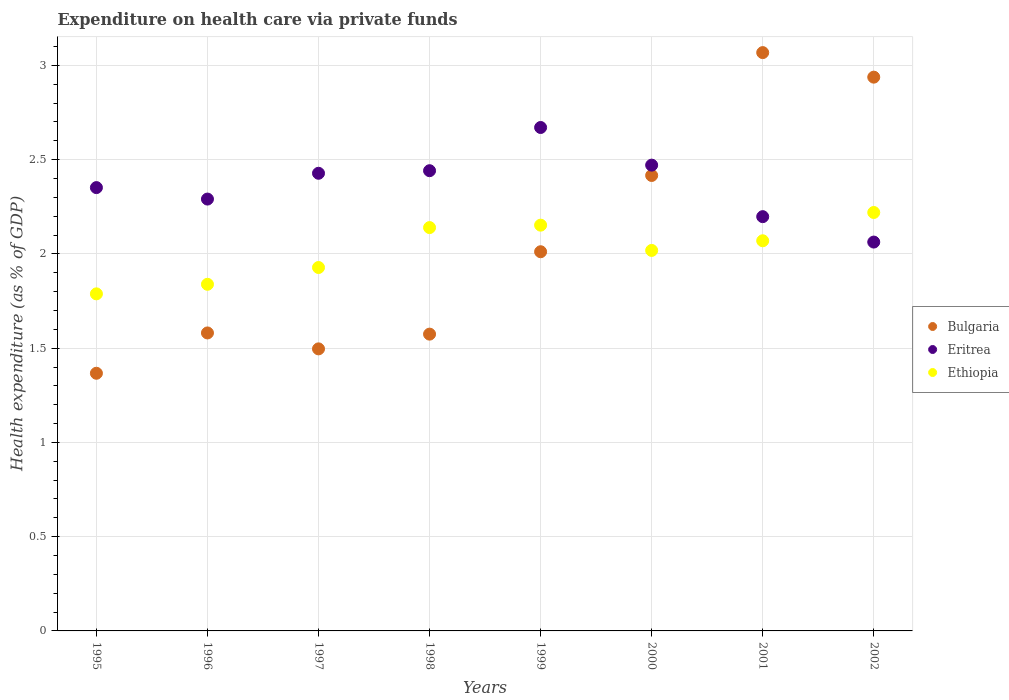Is the number of dotlines equal to the number of legend labels?
Your answer should be very brief. Yes. What is the expenditure made on health care in Ethiopia in 1996?
Provide a succinct answer. 1.84. Across all years, what is the maximum expenditure made on health care in Eritrea?
Your answer should be compact. 2.67. Across all years, what is the minimum expenditure made on health care in Eritrea?
Your response must be concise. 2.06. In which year was the expenditure made on health care in Ethiopia maximum?
Your answer should be compact. 2002. What is the total expenditure made on health care in Ethiopia in the graph?
Ensure brevity in your answer.  16.16. What is the difference between the expenditure made on health care in Eritrea in 1998 and that in 2002?
Your answer should be compact. 0.38. What is the difference between the expenditure made on health care in Ethiopia in 1998 and the expenditure made on health care in Bulgaria in 2001?
Make the answer very short. -0.93. What is the average expenditure made on health care in Ethiopia per year?
Give a very brief answer. 2.02. In the year 1997, what is the difference between the expenditure made on health care in Bulgaria and expenditure made on health care in Ethiopia?
Offer a very short reply. -0.43. What is the ratio of the expenditure made on health care in Ethiopia in 1995 to that in 2001?
Provide a short and direct response. 0.86. Is the expenditure made on health care in Bulgaria in 1995 less than that in 2001?
Give a very brief answer. Yes. What is the difference between the highest and the second highest expenditure made on health care in Ethiopia?
Ensure brevity in your answer.  0.07. What is the difference between the highest and the lowest expenditure made on health care in Ethiopia?
Give a very brief answer. 0.43. In how many years, is the expenditure made on health care in Ethiopia greater than the average expenditure made on health care in Ethiopia taken over all years?
Your answer should be very brief. 4. Is the sum of the expenditure made on health care in Eritrea in 1998 and 1999 greater than the maximum expenditure made on health care in Ethiopia across all years?
Provide a short and direct response. Yes. Is it the case that in every year, the sum of the expenditure made on health care in Ethiopia and expenditure made on health care in Eritrea  is greater than the expenditure made on health care in Bulgaria?
Ensure brevity in your answer.  Yes. Does the expenditure made on health care in Bulgaria monotonically increase over the years?
Offer a very short reply. No. Is the expenditure made on health care in Bulgaria strictly greater than the expenditure made on health care in Ethiopia over the years?
Your answer should be compact. No. How many dotlines are there?
Ensure brevity in your answer.  3. How many years are there in the graph?
Your response must be concise. 8. What is the difference between two consecutive major ticks on the Y-axis?
Your response must be concise. 0.5. Does the graph contain grids?
Offer a very short reply. Yes. Where does the legend appear in the graph?
Keep it short and to the point. Center right. How many legend labels are there?
Offer a very short reply. 3. What is the title of the graph?
Your answer should be compact. Expenditure on health care via private funds. What is the label or title of the X-axis?
Ensure brevity in your answer.  Years. What is the label or title of the Y-axis?
Give a very brief answer. Health expenditure (as % of GDP). What is the Health expenditure (as % of GDP) of Bulgaria in 1995?
Your answer should be compact. 1.37. What is the Health expenditure (as % of GDP) in Eritrea in 1995?
Your response must be concise. 2.35. What is the Health expenditure (as % of GDP) of Ethiopia in 1995?
Your answer should be very brief. 1.79. What is the Health expenditure (as % of GDP) of Bulgaria in 1996?
Offer a terse response. 1.58. What is the Health expenditure (as % of GDP) of Eritrea in 1996?
Your response must be concise. 2.29. What is the Health expenditure (as % of GDP) in Ethiopia in 1996?
Provide a succinct answer. 1.84. What is the Health expenditure (as % of GDP) of Bulgaria in 1997?
Offer a terse response. 1.5. What is the Health expenditure (as % of GDP) in Eritrea in 1997?
Keep it short and to the point. 2.43. What is the Health expenditure (as % of GDP) of Ethiopia in 1997?
Your answer should be very brief. 1.93. What is the Health expenditure (as % of GDP) in Bulgaria in 1998?
Your answer should be very brief. 1.57. What is the Health expenditure (as % of GDP) in Eritrea in 1998?
Provide a short and direct response. 2.44. What is the Health expenditure (as % of GDP) of Ethiopia in 1998?
Your answer should be very brief. 2.14. What is the Health expenditure (as % of GDP) in Bulgaria in 1999?
Your answer should be compact. 2.01. What is the Health expenditure (as % of GDP) of Eritrea in 1999?
Provide a succinct answer. 2.67. What is the Health expenditure (as % of GDP) of Ethiopia in 1999?
Give a very brief answer. 2.15. What is the Health expenditure (as % of GDP) of Bulgaria in 2000?
Keep it short and to the point. 2.42. What is the Health expenditure (as % of GDP) of Eritrea in 2000?
Offer a terse response. 2.47. What is the Health expenditure (as % of GDP) in Ethiopia in 2000?
Provide a short and direct response. 2.02. What is the Health expenditure (as % of GDP) of Bulgaria in 2001?
Offer a very short reply. 3.07. What is the Health expenditure (as % of GDP) of Eritrea in 2001?
Your response must be concise. 2.2. What is the Health expenditure (as % of GDP) in Ethiopia in 2001?
Keep it short and to the point. 2.07. What is the Health expenditure (as % of GDP) of Bulgaria in 2002?
Offer a very short reply. 2.94. What is the Health expenditure (as % of GDP) of Eritrea in 2002?
Make the answer very short. 2.06. What is the Health expenditure (as % of GDP) of Ethiopia in 2002?
Provide a succinct answer. 2.22. Across all years, what is the maximum Health expenditure (as % of GDP) of Bulgaria?
Offer a very short reply. 3.07. Across all years, what is the maximum Health expenditure (as % of GDP) of Eritrea?
Keep it short and to the point. 2.67. Across all years, what is the maximum Health expenditure (as % of GDP) of Ethiopia?
Provide a succinct answer. 2.22. Across all years, what is the minimum Health expenditure (as % of GDP) in Bulgaria?
Keep it short and to the point. 1.37. Across all years, what is the minimum Health expenditure (as % of GDP) in Eritrea?
Your answer should be very brief. 2.06. Across all years, what is the minimum Health expenditure (as % of GDP) in Ethiopia?
Provide a succinct answer. 1.79. What is the total Health expenditure (as % of GDP) of Bulgaria in the graph?
Offer a very short reply. 16.45. What is the total Health expenditure (as % of GDP) of Eritrea in the graph?
Your response must be concise. 18.91. What is the total Health expenditure (as % of GDP) of Ethiopia in the graph?
Keep it short and to the point. 16.16. What is the difference between the Health expenditure (as % of GDP) in Bulgaria in 1995 and that in 1996?
Offer a terse response. -0.21. What is the difference between the Health expenditure (as % of GDP) in Eritrea in 1995 and that in 1996?
Offer a very short reply. 0.06. What is the difference between the Health expenditure (as % of GDP) of Ethiopia in 1995 and that in 1996?
Your answer should be compact. -0.05. What is the difference between the Health expenditure (as % of GDP) in Bulgaria in 1995 and that in 1997?
Offer a very short reply. -0.13. What is the difference between the Health expenditure (as % of GDP) in Eritrea in 1995 and that in 1997?
Provide a short and direct response. -0.08. What is the difference between the Health expenditure (as % of GDP) in Ethiopia in 1995 and that in 1997?
Offer a very short reply. -0.14. What is the difference between the Health expenditure (as % of GDP) of Bulgaria in 1995 and that in 1998?
Your response must be concise. -0.21. What is the difference between the Health expenditure (as % of GDP) of Eritrea in 1995 and that in 1998?
Your response must be concise. -0.09. What is the difference between the Health expenditure (as % of GDP) of Ethiopia in 1995 and that in 1998?
Keep it short and to the point. -0.35. What is the difference between the Health expenditure (as % of GDP) of Bulgaria in 1995 and that in 1999?
Your response must be concise. -0.64. What is the difference between the Health expenditure (as % of GDP) in Eritrea in 1995 and that in 1999?
Provide a short and direct response. -0.32. What is the difference between the Health expenditure (as % of GDP) in Ethiopia in 1995 and that in 1999?
Provide a short and direct response. -0.36. What is the difference between the Health expenditure (as % of GDP) in Bulgaria in 1995 and that in 2000?
Offer a very short reply. -1.05. What is the difference between the Health expenditure (as % of GDP) of Eritrea in 1995 and that in 2000?
Offer a terse response. -0.12. What is the difference between the Health expenditure (as % of GDP) of Ethiopia in 1995 and that in 2000?
Give a very brief answer. -0.23. What is the difference between the Health expenditure (as % of GDP) in Bulgaria in 1995 and that in 2001?
Offer a terse response. -1.7. What is the difference between the Health expenditure (as % of GDP) in Eritrea in 1995 and that in 2001?
Your answer should be very brief. 0.15. What is the difference between the Health expenditure (as % of GDP) of Ethiopia in 1995 and that in 2001?
Keep it short and to the point. -0.28. What is the difference between the Health expenditure (as % of GDP) in Bulgaria in 1995 and that in 2002?
Your response must be concise. -1.57. What is the difference between the Health expenditure (as % of GDP) in Eritrea in 1995 and that in 2002?
Ensure brevity in your answer.  0.29. What is the difference between the Health expenditure (as % of GDP) in Ethiopia in 1995 and that in 2002?
Ensure brevity in your answer.  -0.43. What is the difference between the Health expenditure (as % of GDP) of Bulgaria in 1996 and that in 1997?
Your response must be concise. 0.08. What is the difference between the Health expenditure (as % of GDP) in Eritrea in 1996 and that in 1997?
Make the answer very short. -0.14. What is the difference between the Health expenditure (as % of GDP) of Ethiopia in 1996 and that in 1997?
Your answer should be compact. -0.09. What is the difference between the Health expenditure (as % of GDP) in Bulgaria in 1996 and that in 1998?
Offer a terse response. 0.01. What is the difference between the Health expenditure (as % of GDP) in Eritrea in 1996 and that in 1998?
Keep it short and to the point. -0.15. What is the difference between the Health expenditure (as % of GDP) in Ethiopia in 1996 and that in 1998?
Your response must be concise. -0.3. What is the difference between the Health expenditure (as % of GDP) of Bulgaria in 1996 and that in 1999?
Your answer should be very brief. -0.43. What is the difference between the Health expenditure (as % of GDP) in Eritrea in 1996 and that in 1999?
Offer a terse response. -0.38. What is the difference between the Health expenditure (as % of GDP) in Ethiopia in 1996 and that in 1999?
Keep it short and to the point. -0.31. What is the difference between the Health expenditure (as % of GDP) of Bulgaria in 1996 and that in 2000?
Your response must be concise. -0.84. What is the difference between the Health expenditure (as % of GDP) in Eritrea in 1996 and that in 2000?
Provide a short and direct response. -0.18. What is the difference between the Health expenditure (as % of GDP) of Ethiopia in 1996 and that in 2000?
Ensure brevity in your answer.  -0.18. What is the difference between the Health expenditure (as % of GDP) in Bulgaria in 1996 and that in 2001?
Your answer should be compact. -1.49. What is the difference between the Health expenditure (as % of GDP) of Eritrea in 1996 and that in 2001?
Provide a succinct answer. 0.09. What is the difference between the Health expenditure (as % of GDP) in Ethiopia in 1996 and that in 2001?
Provide a succinct answer. -0.23. What is the difference between the Health expenditure (as % of GDP) in Bulgaria in 1996 and that in 2002?
Your answer should be compact. -1.36. What is the difference between the Health expenditure (as % of GDP) of Eritrea in 1996 and that in 2002?
Provide a short and direct response. 0.23. What is the difference between the Health expenditure (as % of GDP) of Ethiopia in 1996 and that in 2002?
Give a very brief answer. -0.38. What is the difference between the Health expenditure (as % of GDP) in Bulgaria in 1997 and that in 1998?
Provide a short and direct response. -0.08. What is the difference between the Health expenditure (as % of GDP) in Eritrea in 1997 and that in 1998?
Provide a short and direct response. -0.01. What is the difference between the Health expenditure (as % of GDP) of Ethiopia in 1997 and that in 1998?
Make the answer very short. -0.21. What is the difference between the Health expenditure (as % of GDP) of Bulgaria in 1997 and that in 1999?
Offer a very short reply. -0.52. What is the difference between the Health expenditure (as % of GDP) in Eritrea in 1997 and that in 1999?
Keep it short and to the point. -0.24. What is the difference between the Health expenditure (as % of GDP) of Ethiopia in 1997 and that in 1999?
Keep it short and to the point. -0.22. What is the difference between the Health expenditure (as % of GDP) of Bulgaria in 1997 and that in 2000?
Provide a short and direct response. -0.92. What is the difference between the Health expenditure (as % of GDP) in Eritrea in 1997 and that in 2000?
Offer a very short reply. -0.04. What is the difference between the Health expenditure (as % of GDP) in Ethiopia in 1997 and that in 2000?
Ensure brevity in your answer.  -0.09. What is the difference between the Health expenditure (as % of GDP) in Bulgaria in 1997 and that in 2001?
Make the answer very short. -1.57. What is the difference between the Health expenditure (as % of GDP) of Eritrea in 1997 and that in 2001?
Make the answer very short. 0.23. What is the difference between the Health expenditure (as % of GDP) in Ethiopia in 1997 and that in 2001?
Your answer should be very brief. -0.14. What is the difference between the Health expenditure (as % of GDP) of Bulgaria in 1997 and that in 2002?
Make the answer very short. -1.44. What is the difference between the Health expenditure (as % of GDP) of Eritrea in 1997 and that in 2002?
Keep it short and to the point. 0.36. What is the difference between the Health expenditure (as % of GDP) in Ethiopia in 1997 and that in 2002?
Give a very brief answer. -0.29. What is the difference between the Health expenditure (as % of GDP) of Bulgaria in 1998 and that in 1999?
Provide a succinct answer. -0.44. What is the difference between the Health expenditure (as % of GDP) in Eritrea in 1998 and that in 1999?
Provide a short and direct response. -0.23. What is the difference between the Health expenditure (as % of GDP) of Ethiopia in 1998 and that in 1999?
Make the answer very short. -0.01. What is the difference between the Health expenditure (as % of GDP) of Bulgaria in 1998 and that in 2000?
Give a very brief answer. -0.84. What is the difference between the Health expenditure (as % of GDP) in Eritrea in 1998 and that in 2000?
Give a very brief answer. -0.03. What is the difference between the Health expenditure (as % of GDP) in Ethiopia in 1998 and that in 2000?
Provide a succinct answer. 0.12. What is the difference between the Health expenditure (as % of GDP) of Bulgaria in 1998 and that in 2001?
Ensure brevity in your answer.  -1.49. What is the difference between the Health expenditure (as % of GDP) of Eritrea in 1998 and that in 2001?
Your answer should be very brief. 0.24. What is the difference between the Health expenditure (as % of GDP) in Ethiopia in 1998 and that in 2001?
Your answer should be compact. 0.07. What is the difference between the Health expenditure (as % of GDP) of Bulgaria in 1998 and that in 2002?
Your answer should be very brief. -1.36. What is the difference between the Health expenditure (as % of GDP) of Eritrea in 1998 and that in 2002?
Provide a succinct answer. 0.38. What is the difference between the Health expenditure (as % of GDP) in Ethiopia in 1998 and that in 2002?
Your answer should be compact. -0.08. What is the difference between the Health expenditure (as % of GDP) in Bulgaria in 1999 and that in 2000?
Your answer should be compact. -0.4. What is the difference between the Health expenditure (as % of GDP) of Eritrea in 1999 and that in 2000?
Give a very brief answer. 0.2. What is the difference between the Health expenditure (as % of GDP) in Ethiopia in 1999 and that in 2000?
Offer a very short reply. 0.13. What is the difference between the Health expenditure (as % of GDP) of Bulgaria in 1999 and that in 2001?
Ensure brevity in your answer.  -1.06. What is the difference between the Health expenditure (as % of GDP) of Eritrea in 1999 and that in 2001?
Make the answer very short. 0.47. What is the difference between the Health expenditure (as % of GDP) of Ethiopia in 1999 and that in 2001?
Offer a terse response. 0.08. What is the difference between the Health expenditure (as % of GDP) of Bulgaria in 1999 and that in 2002?
Make the answer very short. -0.93. What is the difference between the Health expenditure (as % of GDP) of Eritrea in 1999 and that in 2002?
Give a very brief answer. 0.61. What is the difference between the Health expenditure (as % of GDP) in Ethiopia in 1999 and that in 2002?
Keep it short and to the point. -0.07. What is the difference between the Health expenditure (as % of GDP) of Bulgaria in 2000 and that in 2001?
Offer a terse response. -0.65. What is the difference between the Health expenditure (as % of GDP) in Eritrea in 2000 and that in 2001?
Ensure brevity in your answer.  0.27. What is the difference between the Health expenditure (as % of GDP) of Ethiopia in 2000 and that in 2001?
Give a very brief answer. -0.05. What is the difference between the Health expenditure (as % of GDP) in Bulgaria in 2000 and that in 2002?
Your answer should be compact. -0.52. What is the difference between the Health expenditure (as % of GDP) of Eritrea in 2000 and that in 2002?
Provide a succinct answer. 0.41. What is the difference between the Health expenditure (as % of GDP) in Ethiopia in 2000 and that in 2002?
Offer a terse response. -0.2. What is the difference between the Health expenditure (as % of GDP) of Bulgaria in 2001 and that in 2002?
Offer a very short reply. 0.13. What is the difference between the Health expenditure (as % of GDP) in Eritrea in 2001 and that in 2002?
Give a very brief answer. 0.13. What is the difference between the Health expenditure (as % of GDP) of Ethiopia in 2001 and that in 2002?
Offer a terse response. -0.15. What is the difference between the Health expenditure (as % of GDP) in Bulgaria in 1995 and the Health expenditure (as % of GDP) in Eritrea in 1996?
Provide a succinct answer. -0.92. What is the difference between the Health expenditure (as % of GDP) in Bulgaria in 1995 and the Health expenditure (as % of GDP) in Ethiopia in 1996?
Your response must be concise. -0.47. What is the difference between the Health expenditure (as % of GDP) in Eritrea in 1995 and the Health expenditure (as % of GDP) in Ethiopia in 1996?
Provide a succinct answer. 0.51. What is the difference between the Health expenditure (as % of GDP) in Bulgaria in 1995 and the Health expenditure (as % of GDP) in Eritrea in 1997?
Ensure brevity in your answer.  -1.06. What is the difference between the Health expenditure (as % of GDP) of Bulgaria in 1995 and the Health expenditure (as % of GDP) of Ethiopia in 1997?
Provide a short and direct response. -0.56. What is the difference between the Health expenditure (as % of GDP) in Eritrea in 1995 and the Health expenditure (as % of GDP) in Ethiopia in 1997?
Keep it short and to the point. 0.42. What is the difference between the Health expenditure (as % of GDP) of Bulgaria in 1995 and the Health expenditure (as % of GDP) of Eritrea in 1998?
Ensure brevity in your answer.  -1.07. What is the difference between the Health expenditure (as % of GDP) in Bulgaria in 1995 and the Health expenditure (as % of GDP) in Ethiopia in 1998?
Offer a very short reply. -0.77. What is the difference between the Health expenditure (as % of GDP) in Eritrea in 1995 and the Health expenditure (as % of GDP) in Ethiopia in 1998?
Ensure brevity in your answer.  0.21. What is the difference between the Health expenditure (as % of GDP) of Bulgaria in 1995 and the Health expenditure (as % of GDP) of Eritrea in 1999?
Keep it short and to the point. -1.3. What is the difference between the Health expenditure (as % of GDP) in Bulgaria in 1995 and the Health expenditure (as % of GDP) in Ethiopia in 1999?
Provide a short and direct response. -0.79. What is the difference between the Health expenditure (as % of GDP) in Eritrea in 1995 and the Health expenditure (as % of GDP) in Ethiopia in 1999?
Offer a terse response. 0.2. What is the difference between the Health expenditure (as % of GDP) in Bulgaria in 1995 and the Health expenditure (as % of GDP) in Eritrea in 2000?
Ensure brevity in your answer.  -1.1. What is the difference between the Health expenditure (as % of GDP) in Bulgaria in 1995 and the Health expenditure (as % of GDP) in Ethiopia in 2000?
Keep it short and to the point. -0.65. What is the difference between the Health expenditure (as % of GDP) in Bulgaria in 1995 and the Health expenditure (as % of GDP) in Eritrea in 2001?
Offer a terse response. -0.83. What is the difference between the Health expenditure (as % of GDP) in Bulgaria in 1995 and the Health expenditure (as % of GDP) in Ethiopia in 2001?
Your response must be concise. -0.7. What is the difference between the Health expenditure (as % of GDP) of Eritrea in 1995 and the Health expenditure (as % of GDP) of Ethiopia in 2001?
Offer a very short reply. 0.28. What is the difference between the Health expenditure (as % of GDP) of Bulgaria in 1995 and the Health expenditure (as % of GDP) of Eritrea in 2002?
Your response must be concise. -0.7. What is the difference between the Health expenditure (as % of GDP) of Bulgaria in 1995 and the Health expenditure (as % of GDP) of Ethiopia in 2002?
Your answer should be compact. -0.85. What is the difference between the Health expenditure (as % of GDP) in Eritrea in 1995 and the Health expenditure (as % of GDP) in Ethiopia in 2002?
Your answer should be compact. 0.13. What is the difference between the Health expenditure (as % of GDP) of Bulgaria in 1996 and the Health expenditure (as % of GDP) of Eritrea in 1997?
Your response must be concise. -0.85. What is the difference between the Health expenditure (as % of GDP) of Bulgaria in 1996 and the Health expenditure (as % of GDP) of Ethiopia in 1997?
Ensure brevity in your answer.  -0.35. What is the difference between the Health expenditure (as % of GDP) of Eritrea in 1996 and the Health expenditure (as % of GDP) of Ethiopia in 1997?
Your response must be concise. 0.36. What is the difference between the Health expenditure (as % of GDP) in Bulgaria in 1996 and the Health expenditure (as % of GDP) in Eritrea in 1998?
Offer a very short reply. -0.86. What is the difference between the Health expenditure (as % of GDP) of Bulgaria in 1996 and the Health expenditure (as % of GDP) of Ethiopia in 1998?
Make the answer very short. -0.56. What is the difference between the Health expenditure (as % of GDP) of Eritrea in 1996 and the Health expenditure (as % of GDP) of Ethiopia in 1998?
Ensure brevity in your answer.  0.15. What is the difference between the Health expenditure (as % of GDP) of Bulgaria in 1996 and the Health expenditure (as % of GDP) of Eritrea in 1999?
Your answer should be very brief. -1.09. What is the difference between the Health expenditure (as % of GDP) in Bulgaria in 1996 and the Health expenditure (as % of GDP) in Ethiopia in 1999?
Offer a very short reply. -0.57. What is the difference between the Health expenditure (as % of GDP) of Eritrea in 1996 and the Health expenditure (as % of GDP) of Ethiopia in 1999?
Your response must be concise. 0.14. What is the difference between the Health expenditure (as % of GDP) of Bulgaria in 1996 and the Health expenditure (as % of GDP) of Eritrea in 2000?
Provide a short and direct response. -0.89. What is the difference between the Health expenditure (as % of GDP) of Bulgaria in 1996 and the Health expenditure (as % of GDP) of Ethiopia in 2000?
Make the answer very short. -0.44. What is the difference between the Health expenditure (as % of GDP) in Eritrea in 1996 and the Health expenditure (as % of GDP) in Ethiopia in 2000?
Your answer should be compact. 0.27. What is the difference between the Health expenditure (as % of GDP) of Bulgaria in 1996 and the Health expenditure (as % of GDP) of Eritrea in 2001?
Provide a succinct answer. -0.62. What is the difference between the Health expenditure (as % of GDP) in Bulgaria in 1996 and the Health expenditure (as % of GDP) in Ethiopia in 2001?
Your response must be concise. -0.49. What is the difference between the Health expenditure (as % of GDP) in Eritrea in 1996 and the Health expenditure (as % of GDP) in Ethiopia in 2001?
Provide a succinct answer. 0.22. What is the difference between the Health expenditure (as % of GDP) of Bulgaria in 1996 and the Health expenditure (as % of GDP) of Eritrea in 2002?
Give a very brief answer. -0.48. What is the difference between the Health expenditure (as % of GDP) in Bulgaria in 1996 and the Health expenditure (as % of GDP) in Ethiopia in 2002?
Your answer should be compact. -0.64. What is the difference between the Health expenditure (as % of GDP) in Eritrea in 1996 and the Health expenditure (as % of GDP) in Ethiopia in 2002?
Your answer should be compact. 0.07. What is the difference between the Health expenditure (as % of GDP) of Bulgaria in 1997 and the Health expenditure (as % of GDP) of Eritrea in 1998?
Ensure brevity in your answer.  -0.95. What is the difference between the Health expenditure (as % of GDP) in Bulgaria in 1997 and the Health expenditure (as % of GDP) in Ethiopia in 1998?
Make the answer very short. -0.64. What is the difference between the Health expenditure (as % of GDP) of Eritrea in 1997 and the Health expenditure (as % of GDP) of Ethiopia in 1998?
Your response must be concise. 0.29. What is the difference between the Health expenditure (as % of GDP) of Bulgaria in 1997 and the Health expenditure (as % of GDP) of Eritrea in 1999?
Provide a succinct answer. -1.17. What is the difference between the Health expenditure (as % of GDP) of Bulgaria in 1997 and the Health expenditure (as % of GDP) of Ethiopia in 1999?
Ensure brevity in your answer.  -0.66. What is the difference between the Health expenditure (as % of GDP) in Eritrea in 1997 and the Health expenditure (as % of GDP) in Ethiopia in 1999?
Offer a very short reply. 0.28. What is the difference between the Health expenditure (as % of GDP) of Bulgaria in 1997 and the Health expenditure (as % of GDP) of Eritrea in 2000?
Your response must be concise. -0.97. What is the difference between the Health expenditure (as % of GDP) in Bulgaria in 1997 and the Health expenditure (as % of GDP) in Ethiopia in 2000?
Your answer should be very brief. -0.52. What is the difference between the Health expenditure (as % of GDP) of Eritrea in 1997 and the Health expenditure (as % of GDP) of Ethiopia in 2000?
Offer a terse response. 0.41. What is the difference between the Health expenditure (as % of GDP) of Bulgaria in 1997 and the Health expenditure (as % of GDP) of Eritrea in 2001?
Offer a very short reply. -0.7. What is the difference between the Health expenditure (as % of GDP) of Bulgaria in 1997 and the Health expenditure (as % of GDP) of Ethiopia in 2001?
Offer a very short reply. -0.57. What is the difference between the Health expenditure (as % of GDP) in Eritrea in 1997 and the Health expenditure (as % of GDP) in Ethiopia in 2001?
Your answer should be very brief. 0.36. What is the difference between the Health expenditure (as % of GDP) in Bulgaria in 1997 and the Health expenditure (as % of GDP) in Eritrea in 2002?
Make the answer very short. -0.57. What is the difference between the Health expenditure (as % of GDP) of Bulgaria in 1997 and the Health expenditure (as % of GDP) of Ethiopia in 2002?
Provide a succinct answer. -0.72. What is the difference between the Health expenditure (as % of GDP) in Eritrea in 1997 and the Health expenditure (as % of GDP) in Ethiopia in 2002?
Keep it short and to the point. 0.21. What is the difference between the Health expenditure (as % of GDP) of Bulgaria in 1998 and the Health expenditure (as % of GDP) of Eritrea in 1999?
Offer a very short reply. -1.1. What is the difference between the Health expenditure (as % of GDP) of Bulgaria in 1998 and the Health expenditure (as % of GDP) of Ethiopia in 1999?
Give a very brief answer. -0.58. What is the difference between the Health expenditure (as % of GDP) in Eritrea in 1998 and the Health expenditure (as % of GDP) in Ethiopia in 1999?
Ensure brevity in your answer.  0.29. What is the difference between the Health expenditure (as % of GDP) in Bulgaria in 1998 and the Health expenditure (as % of GDP) in Eritrea in 2000?
Offer a terse response. -0.9. What is the difference between the Health expenditure (as % of GDP) of Bulgaria in 1998 and the Health expenditure (as % of GDP) of Ethiopia in 2000?
Your answer should be compact. -0.44. What is the difference between the Health expenditure (as % of GDP) of Eritrea in 1998 and the Health expenditure (as % of GDP) of Ethiopia in 2000?
Your answer should be compact. 0.42. What is the difference between the Health expenditure (as % of GDP) in Bulgaria in 1998 and the Health expenditure (as % of GDP) in Eritrea in 2001?
Ensure brevity in your answer.  -0.62. What is the difference between the Health expenditure (as % of GDP) in Bulgaria in 1998 and the Health expenditure (as % of GDP) in Ethiopia in 2001?
Offer a terse response. -0.5. What is the difference between the Health expenditure (as % of GDP) in Eritrea in 1998 and the Health expenditure (as % of GDP) in Ethiopia in 2001?
Your answer should be very brief. 0.37. What is the difference between the Health expenditure (as % of GDP) in Bulgaria in 1998 and the Health expenditure (as % of GDP) in Eritrea in 2002?
Offer a terse response. -0.49. What is the difference between the Health expenditure (as % of GDP) of Bulgaria in 1998 and the Health expenditure (as % of GDP) of Ethiopia in 2002?
Your answer should be very brief. -0.65. What is the difference between the Health expenditure (as % of GDP) of Eritrea in 1998 and the Health expenditure (as % of GDP) of Ethiopia in 2002?
Make the answer very short. 0.22. What is the difference between the Health expenditure (as % of GDP) in Bulgaria in 1999 and the Health expenditure (as % of GDP) in Eritrea in 2000?
Offer a terse response. -0.46. What is the difference between the Health expenditure (as % of GDP) of Bulgaria in 1999 and the Health expenditure (as % of GDP) of Ethiopia in 2000?
Your answer should be very brief. -0.01. What is the difference between the Health expenditure (as % of GDP) in Eritrea in 1999 and the Health expenditure (as % of GDP) in Ethiopia in 2000?
Your answer should be compact. 0.65. What is the difference between the Health expenditure (as % of GDP) of Bulgaria in 1999 and the Health expenditure (as % of GDP) of Eritrea in 2001?
Offer a terse response. -0.19. What is the difference between the Health expenditure (as % of GDP) of Bulgaria in 1999 and the Health expenditure (as % of GDP) of Ethiopia in 2001?
Provide a succinct answer. -0.06. What is the difference between the Health expenditure (as % of GDP) in Eritrea in 1999 and the Health expenditure (as % of GDP) in Ethiopia in 2001?
Your answer should be very brief. 0.6. What is the difference between the Health expenditure (as % of GDP) in Bulgaria in 1999 and the Health expenditure (as % of GDP) in Eritrea in 2002?
Your answer should be very brief. -0.05. What is the difference between the Health expenditure (as % of GDP) of Bulgaria in 1999 and the Health expenditure (as % of GDP) of Ethiopia in 2002?
Offer a very short reply. -0.21. What is the difference between the Health expenditure (as % of GDP) in Eritrea in 1999 and the Health expenditure (as % of GDP) in Ethiopia in 2002?
Your response must be concise. 0.45. What is the difference between the Health expenditure (as % of GDP) of Bulgaria in 2000 and the Health expenditure (as % of GDP) of Eritrea in 2001?
Your answer should be very brief. 0.22. What is the difference between the Health expenditure (as % of GDP) in Bulgaria in 2000 and the Health expenditure (as % of GDP) in Ethiopia in 2001?
Your answer should be compact. 0.35. What is the difference between the Health expenditure (as % of GDP) of Eritrea in 2000 and the Health expenditure (as % of GDP) of Ethiopia in 2001?
Ensure brevity in your answer.  0.4. What is the difference between the Health expenditure (as % of GDP) in Bulgaria in 2000 and the Health expenditure (as % of GDP) in Eritrea in 2002?
Your answer should be very brief. 0.35. What is the difference between the Health expenditure (as % of GDP) of Bulgaria in 2000 and the Health expenditure (as % of GDP) of Ethiopia in 2002?
Your response must be concise. 0.2. What is the difference between the Health expenditure (as % of GDP) in Eritrea in 2000 and the Health expenditure (as % of GDP) in Ethiopia in 2002?
Your response must be concise. 0.25. What is the difference between the Health expenditure (as % of GDP) of Bulgaria in 2001 and the Health expenditure (as % of GDP) of Eritrea in 2002?
Offer a very short reply. 1.01. What is the difference between the Health expenditure (as % of GDP) in Bulgaria in 2001 and the Health expenditure (as % of GDP) in Ethiopia in 2002?
Provide a short and direct response. 0.85. What is the difference between the Health expenditure (as % of GDP) in Eritrea in 2001 and the Health expenditure (as % of GDP) in Ethiopia in 2002?
Provide a short and direct response. -0.02. What is the average Health expenditure (as % of GDP) in Bulgaria per year?
Offer a terse response. 2.06. What is the average Health expenditure (as % of GDP) of Eritrea per year?
Offer a very short reply. 2.36. What is the average Health expenditure (as % of GDP) of Ethiopia per year?
Offer a very short reply. 2.02. In the year 1995, what is the difference between the Health expenditure (as % of GDP) of Bulgaria and Health expenditure (as % of GDP) of Eritrea?
Your response must be concise. -0.98. In the year 1995, what is the difference between the Health expenditure (as % of GDP) of Bulgaria and Health expenditure (as % of GDP) of Ethiopia?
Offer a terse response. -0.42. In the year 1995, what is the difference between the Health expenditure (as % of GDP) in Eritrea and Health expenditure (as % of GDP) in Ethiopia?
Make the answer very short. 0.56. In the year 1996, what is the difference between the Health expenditure (as % of GDP) of Bulgaria and Health expenditure (as % of GDP) of Eritrea?
Offer a terse response. -0.71. In the year 1996, what is the difference between the Health expenditure (as % of GDP) in Bulgaria and Health expenditure (as % of GDP) in Ethiopia?
Your response must be concise. -0.26. In the year 1996, what is the difference between the Health expenditure (as % of GDP) of Eritrea and Health expenditure (as % of GDP) of Ethiopia?
Give a very brief answer. 0.45. In the year 1997, what is the difference between the Health expenditure (as % of GDP) in Bulgaria and Health expenditure (as % of GDP) in Eritrea?
Offer a terse response. -0.93. In the year 1997, what is the difference between the Health expenditure (as % of GDP) of Bulgaria and Health expenditure (as % of GDP) of Ethiopia?
Ensure brevity in your answer.  -0.43. In the year 1997, what is the difference between the Health expenditure (as % of GDP) in Eritrea and Health expenditure (as % of GDP) in Ethiopia?
Your answer should be very brief. 0.5. In the year 1998, what is the difference between the Health expenditure (as % of GDP) in Bulgaria and Health expenditure (as % of GDP) in Eritrea?
Provide a short and direct response. -0.87. In the year 1998, what is the difference between the Health expenditure (as % of GDP) in Bulgaria and Health expenditure (as % of GDP) in Ethiopia?
Offer a terse response. -0.57. In the year 1998, what is the difference between the Health expenditure (as % of GDP) of Eritrea and Health expenditure (as % of GDP) of Ethiopia?
Your answer should be compact. 0.3. In the year 1999, what is the difference between the Health expenditure (as % of GDP) in Bulgaria and Health expenditure (as % of GDP) in Eritrea?
Provide a succinct answer. -0.66. In the year 1999, what is the difference between the Health expenditure (as % of GDP) in Bulgaria and Health expenditure (as % of GDP) in Ethiopia?
Offer a terse response. -0.14. In the year 1999, what is the difference between the Health expenditure (as % of GDP) of Eritrea and Health expenditure (as % of GDP) of Ethiopia?
Provide a succinct answer. 0.52. In the year 2000, what is the difference between the Health expenditure (as % of GDP) of Bulgaria and Health expenditure (as % of GDP) of Eritrea?
Provide a succinct answer. -0.05. In the year 2000, what is the difference between the Health expenditure (as % of GDP) of Bulgaria and Health expenditure (as % of GDP) of Ethiopia?
Offer a very short reply. 0.4. In the year 2000, what is the difference between the Health expenditure (as % of GDP) in Eritrea and Health expenditure (as % of GDP) in Ethiopia?
Your answer should be very brief. 0.45. In the year 2001, what is the difference between the Health expenditure (as % of GDP) of Bulgaria and Health expenditure (as % of GDP) of Eritrea?
Give a very brief answer. 0.87. In the year 2001, what is the difference between the Health expenditure (as % of GDP) of Bulgaria and Health expenditure (as % of GDP) of Ethiopia?
Your response must be concise. 1. In the year 2001, what is the difference between the Health expenditure (as % of GDP) of Eritrea and Health expenditure (as % of GDP) of Ethiopia?
Offer a very short reply. 0.13. In the year 2002, what is the difference between the Health expenditure (as % of GDP) of Bulgaria and Health expenditure (as % of GDP) of Eritrea?
Your response must be concise. 0.87. In the year 2002, what is the difference between the Health expenditure (as % of GDP) of Bulgaria and Health expenditure (as % of GDP) of Ethiopia?
Offer a terse response. 0.72. In the year 2002, what is the difference between the Health expenditure (as % of GDP) of Eritrea and Health expenditure (as % of GDP) of Ethiopia?
Give a very brief answer. -0.16. What is the ratio of the Health expenditure (as % of GDP) in Bulgaria in 1995 to that in 1996?
Your response must be concise. 0.86. What is the ratio of the Health expenditure (as % of GDP) of Eritrea in 1995 to that in 1996?
Offer a very short reply. 1.03. What is the ratio of the Health expenditure (as % of GDP) in Ethiopia in 1995 to that in 1996?
Give a very brief answer. 0.97. What is the ratio of the Health expenditure (as % of GDP) of Bulgaria in 1995 to that in 1997?
Offer a very short reply. 0.91. What is the ratio of the Health expenditure (as % of GDP) of Eritrea in 1995 to that in 1997?
Offer a very short reply. 0.97. What is the ratio of the Health expenditure (as % of GDP) of Ethiopia in 1995 to that in 1997?
Give a very brief answer. 0.93. What is the ratio of the Health expenditure (as % of GDP) in Bulgaria in 1995 to that in 1998?
Your answer should be very brief. 0.87. What is the ratio of the Health expenditure (as % of GDP) of Eritrea in 1995 to that in 1998?
Make the answer very short. 0.96. What is the ratio of the Health expenditure (as % of GDP) of Ethiopia in 1995 to that in 1998?
Provide a short and direct response. 0.84. What is the ratio of the Health expenditure (as % of GDP) of Bulgaria in 1995 to that in 1999?
Give a very brief answer. 0.68. What is the ratio of the Health expenditure (as % of GDP) of Eritrea in 1995 to that in 1999?
Give a very brief answer. 0.88. What is the ratio of the Health expenditure (as % of GDP) of Ethiopia in 1995 to that in 1999?
Provide a succinct answer. 0.83. What is the ratio of the Health expenditure (as % of GDP) of Bulgaria in 1995 to that in 2000?
Offer a terse response. 0.57. What is the ratio of the Health expenditure (as % of GDP) of Eritrea in 1995 to that in 2000?
Provide a succinct answer. 0.95. What is the ratio of the Health expenditure (as % of GDP) of Ethiopia in 1995 to that in 2000?
Offer a terse response. 0.89. What is the ratio of the Health expenditure (as % of GDP) in Bulgaria in 1995 to that in 2001?
Your answer should be compact. 0.45. What is the ratio of the Health expenditure (as % of GDP) of Eritrea in 1995 to that in 2001?
Your response must be concise. 1.07. What is the ratio of the Health expenditure (as % of GDP) of Ethiopia in 1995 to that in 2001?
Your answer should be very brief. 0.86. What is the ratio of the Health expenditure (as % of GDP) of Bulgaria in 1995 to that in 2002?
Make the answer very short. 0.47. What is the ratio of the Health expenditure (as % of GDP) of Eritrea in 1995 to that in 2002?
Your response must be concise. 1.14. What is the ratio of the Health expenditure (as % of GDP) of Ethiopia in 1995 to that in 2002?
Your answer should be very brief. 0.81. What is the ratio of the Health expenditure (as % of GDP) in Bulgaria in 1996 to that in 1997?
Make the answer very short. 1.06. What is the ratio of the Health expenditure (as % of GDP) of Eritrea in 1996 to that in 1997?
Your answer should be very brief. 0.94. What is the ratio of the Health expenditure (as % of GDP) in Ethiopia in 1996 to that in 1997?
Provide a short and direct response. 0.95. What is the ratio of the Health expenditure (as % of GDP) of Bulgaria in 1996 to that in 1998?
Offer a very short reply. 1. What is the ratio of the Health expenditure (as % of GDP) in Eritrea in 1996 to that in 1998?
Offer a terse response. 0.94. What is the ratio of the Health expenditure (as % of GDP) in Ethiopia in 1996 to that in 1998?
Give a very brief answer. 0.86. What is the ratio of the Health expenditure (as % of GDP) of Bulgaria in 1996 to that in 1999?
Ensure brevity in your answer.  0.79. What is the ratio of the Health expenditure (as % of GDP) in Eritrea in 1996 to that in 1999?
Your response must be concise. 0.86. What is the ratio of the Health expenditure (as % of GDP) in Ethiopia in 1996 to that in 1999?
Your response must be concise. 0.85. What is the ratio of the Health expenditure (as % of GDP) in Bulgaria in 1996 to that in 2000?
Ensure brevity in your answer.  0.65. What is the ratio of the Health expenditure (as % of GDP) of Eritrea in 1996 to that in 2000?
Make the answer very short. 0.93. What is the ratio of the Health expenditure (as % of GDP) of Ethiopia in 1996 to that in 2000?
Offer a terse response. 0.91. What is the ratio of the Health expenditure (as % of GDP) of Bulgaria in 1996 to that in 2001?
Your answer should be compact. 0.52. What is the ratio of the Health expenditure (as % of GDP) of Eritrea in 1996 to that in 2001?
Offer a very short reply. 1.04. What is the ratio of the Health expenditure (as % of GDP) in Ethiopia in 1996 to that in 2001?
Keep it short and to the point. 0.89. What is the ratio of the Health expenditure (as % of GDP) of Bulgaria in 1996 to that in 2002?
Offer a terse response. 0.54. What is the ratio of the Health expenditure (as % of GDP) of Eritrea in 1996 to that in 2002?
Offer a terse response. 1.11. What is the ratio of the Health expenditure (as % of GDP) of Ethiopia in 1996 to that in 2002?
Keep it short and to the point. 0.83. What is the ratio of the Health expenditure (as % of GDP) in Bulgaria in 1997 to that in 1998?
Your answer should be very brief. 0.95. What is the ratio of the Health expenditure (as % of GDP) in Ethiopia in 1997 to that in 1998?
Your answer should be compact. 0.9. What is the ratio of the Health expenditure (as % of GDP) of Bulgaria in 1997 to that in 1999?
Your answer should be very brief. 0.74. What is the ratio of the Health expenditure (as % of GDP) in Ethiopia in 1997 to that in 1999?
Make the answer very short. 0.9. What is the ratio of the Health expenditure (as % of GDP) of Bulgaria in 1997 to that in 2000?
Provide a succinct answer. 0.62. What is the ratio of the Health expenditure (as % of GDP) of Eritrea in 1997 to that in 2000?
Provide a short and direct response. 0.98. What is the ratio of the Health expenditure (as % of GDP) of Ethiopia in 1997 to that in 2000?
Offer a very short reply. 0.96. What is the ratio of the Health expenditure (as % of GDP) of Bulgaria in 1997 to that in 2001?
Provide a short and direct response. 0.49. What is the ratio of the Health expenditure (as % of GDP) of Eritrea in 1997 to that in 2001?
Your response must be concise. 1.1. What is the ratio of the Health expenditure (as % of GDP) in Ethiopia in 1997 to that in 2001?
Make the answer very short. 0.93. What is the ratio of the Health expenditure (as % of GDP) in Bulgaria in 1997 to that in 2002?
Ensure brevity in your answer.  0.51. What is the ratio of the Health expenditure (as % of GDP) in Eritrea in 1997 to that in 2002?
Provide a succinct answer. 1.18. What is the ratio of the Health expenditure (as % of GDP) in Ethiopia in 1997 to that in 2002?
Your answer should be very brief. 0.87. What is the ratio of the Health expenditure (as % of GDP) of Bulgaria in 1998 to that in 1999?
Give a very brief answer. 0.78. What is the ratio of the Health expenditure (as % of GDP) in Eritrea in 1998 to that in 1999?
Offer a very short reply. 0.91. What is the ratio of the Health expenditure (as % of GDP) of Ethiopia in 1998 to that in 1999?
Your answer should be compact. 0.99. What is the ratio of the Health expenditure (as % of GDP) in Bulgaria in 1998 to that in 2000?
Your answer should be very brief. 0.65. What is the ratio of the Health expenditure (as % of GDP) in Ethiopia in 1998 to that in 2000?
Your answer should be very brief. 1.06. What is the ratio of the Health expenditure (as % of GDP) of Bulgaria in 1998 to that in 2001?
Offer a very short reply. 0.51. What is the ratio of the Health expenditure (as % of GDP) of Eritrea in 1998 to that in 2001?
Your response must be concise. 1.11. What is the ratio of the Health expenditure (as % of GDP) in Ethiopia in 1998 to that in 2001?
Ensure brevity in your answer.  1.03. What is the ratio of the Health expenditure (as % of GDP) of Bulgaria in 1998 to that in 2002?
Give a very brief answer. 0.54. What is the ratio of the Health expenditure (as % of GDP) in Eritrea in 1998 to that in 2002?
Your answer should be very brief. 1.18. What is the ratio of the Health expenditure (as % of GDP) in Ethiopia in 1998 to that in 2002?
Keep it short and to the point. 0.96. What is the ratio of the Health expenditure (as % of GDP) in Bulgaria in 1999 to that in 2000?
Give a very brief answer. 0.83. What is the ratio of the Health expenditure (as % of GDP) of Eritrea in 1999 to that in 2000?
Your answer should be compact. 1.08. What is the ratio of the Health expenditure (as % of GDP) of Ethiopia in 1999 to that in 2000?
Ensure brevity in your answer.  1.07. What is the ratio of the Health expenditure (as % of GDP) of Bulgaria in 1999 to that in 2001?
Your answer should be very brief. 0.66. What is the ratio of the Health expenditure (as % of GDP) of Eritrea in 1999 to that in 2001?
Provide a short and direct response. 1.22. What is the ratio of the Health expenditure (as % of GDP) of Ethiopia in 1999 to that in 2001?
Offer a very short reply. 1.04. What is the ratio of the Health expenditure (as % of GDP) of Bulgaria in 1999 to that in 2002?
Your answer should be very brief. 0.68. What is the ratio of the Health expenditure (as % of GDP) of Eritrea in 1999 to that in 2002?
Your answer should be compact. 1.29. What is the ratio of the Health expenditure (as % of GDP) of Ethiopia in 1999 to that in 2002?
Give a very brief answer. 0.97. What is the ratio of the Health expenditure (as % of GDP) of Bulgaria in 2000 to that in 2001?
Provide a short and direct response. 0.79. What is the ratio of the Health expenditure (as % of GDP) in Eritrea in 2000 to that in 2001?
Offer a very short reply. 1.12. What is the ratio of the Health expenditure (as % of GDP) in Ethiopia in 2000 to that in 2001?
Make the answer very short. 0.98. What is the ratio of the Health expenditure (as % of GDP) of Bulgaria in 2000 to that in 2002?
Offer a very short reply. 0.82. What is the ratio of the Health expenditure (as % of GDP) in Eritrea in 2000 to that in 2002?
Provide a succinct answer. 1.2. What is the ratio of the Health expenditure (as % of GDP) in Ethiopia in 2000 to that in 2002?
Give a very brief answer. 0.91. What is the ratio of the Health expenditure (as % of GDP) in Bulgaria in 2001 to that in 2002?
Your response must be concise. 1.04. What is the ratio of the Health expenditure (as % of GDP) of Eritrea in 2001 to that in 2002?
Offer a very short reply. 1.07. What is the ratio of the Health expenditure (as % of GDP) of Ethiopia in 2001 to that in 2002?
Your response must be concise. 0.93. What is the difference between the highest and the second highest Health expenditure (as % of GDP) of Bulgaria?
Keep it short and to the point. 0.13. What is the difference between the highest and the second highest Health expenditure (as % of GDP) in Eritrea?
Make the answer very short. 0.2. What is the difference between the highest and the second highest Health expenditure (as % of GDP) in Ethiopia?
Make the answer very short. 0.07. What is the difference between the highest and the lowest Health expenditure (as % of GDP) in Bulgaria?
Your response must be concise. 1.7. What is the difference between the highest and the lowest Health expenditure (as % of GDP) in Eritrea?
Your answer should be very brief. 0.61. What is the difference between the highest and the lowest Health expenditure (as % of GDP) of Ethiopia?
Keep it short and to the point. 0.43. 